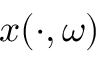Convert formula to latex. <formula><loc_0><loc_0><loc_500><loc_500>x ( \cdot , \omega )</formula> 